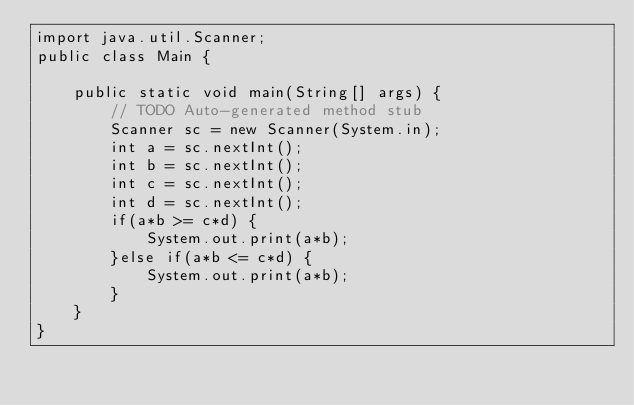<code> <loc_0><loc_0><loc_500><loc_500><_Java_>import java.util.Scanner;
public class Main {

	public static void main(String[] args) {
		// TODO Auto-generated method stub
		Scanner sc = new Scanner(System.in);
		int a = sc.nextInt();
		int b = sc.nextInt();
		int c = sc.nextInt();
		int d = sc.nextInt();
		if(a*b >= c*d) {
			System.out.print(a*b);
		}else if(a*b <= c*d) {
			System.out.print(a*b);
		}
	}
}
</code> 